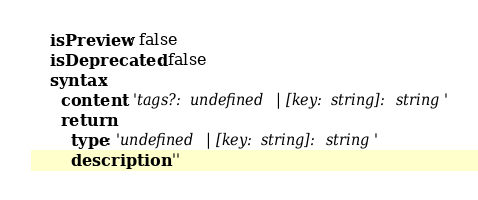<code> <loc_0><loc_0><loc_500><loc_500><_YAML_>    isPreview: false
    isDeprecated: false
    syntax:
      content: 'tags?: undefined | [key: string]: string'
      return:
        type: 'undefined | [key: string]: string'
        description: ''
</code> 